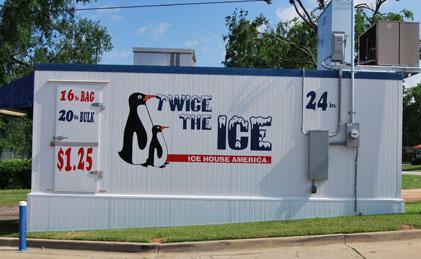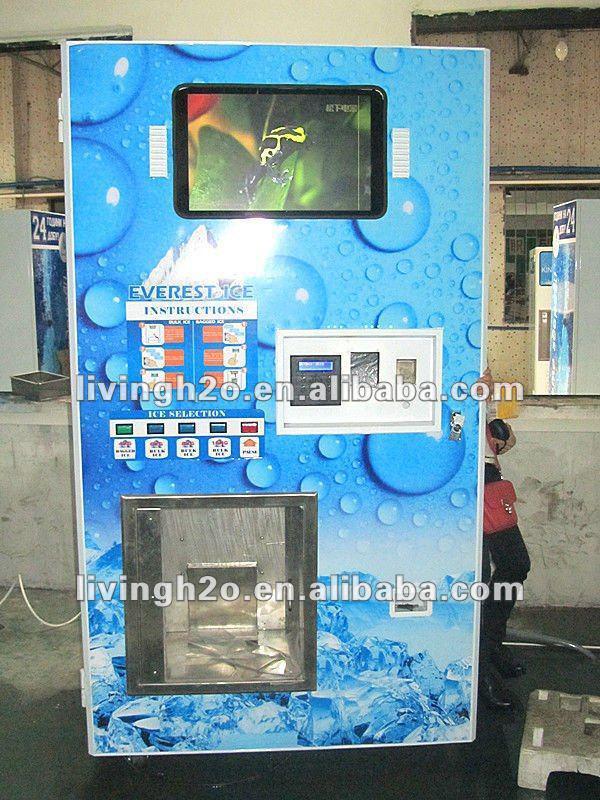The first image is the image on the left, the second image is the image on the right. Assess this claim about the two images: "A person is standing in front of one of the ice machines.". Correct or not? Answer yes or no. No. The first image is the image on the left, the second image is the image on the right. Examine the images to the left and right. Is the description "There are at least two painted penguins on the side of a ice house with blue trim." accurate? Answer yes or no. Yes. 